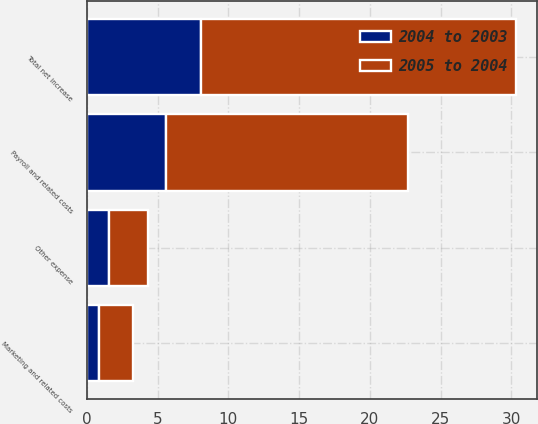<chart> <loc_0><loc_0><loc_500><loc_500><stacked_bar_chart><ecel><fcel>Payroll and related costs<fcel>Marketing and related costs<fcel>Other expense<fcel>Total net increase<nl><fcel>2005 to 2004<fcel>17.1<fcel>2.4<fcel>2.7<fcel>22.2<nl><fcel>2004 to 2003<fcel>5.6<fcel>0.9<fcel>1.6<fcel>8.1<nl></chart> 